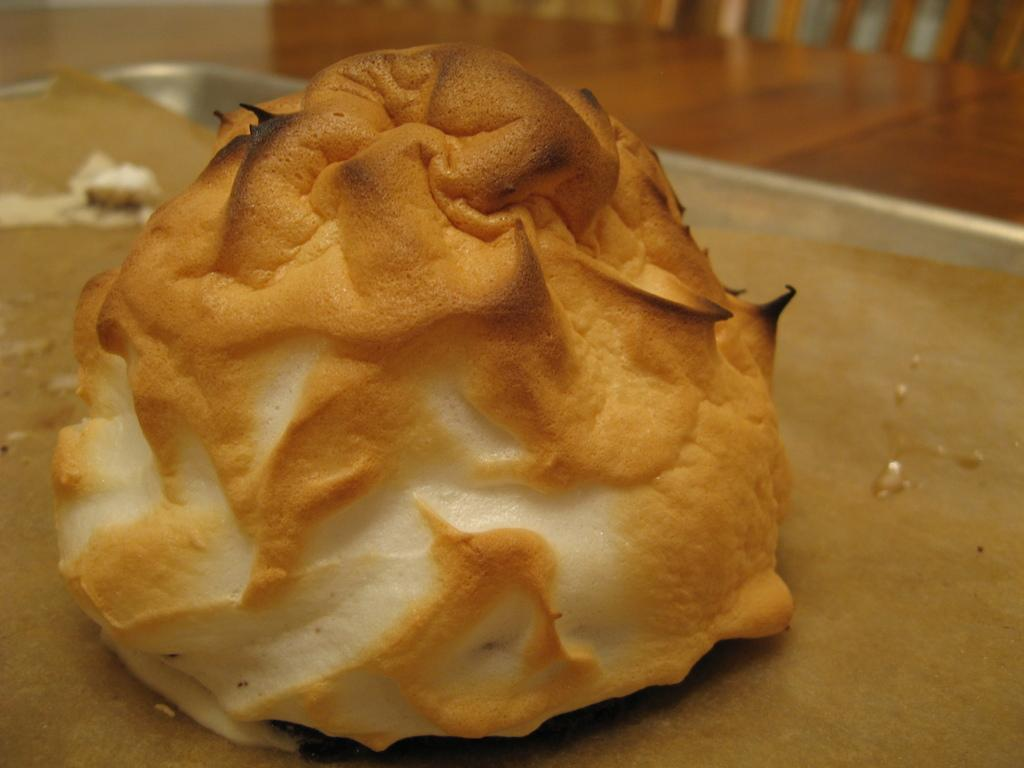What is the main subject in the center of the image? There is a food item in the center of the image. What is the surface on which the food item and other items are placed? There are other items on a wooden table. Can you describe any objects visible in the background of the image? Unfortunately, the provided facts do not give any information about the objects visible in the background of the image. What type of grape is being used in the competition depicted in the image? There is no competition or grape present in the image; it features a food item on a wooden table. 